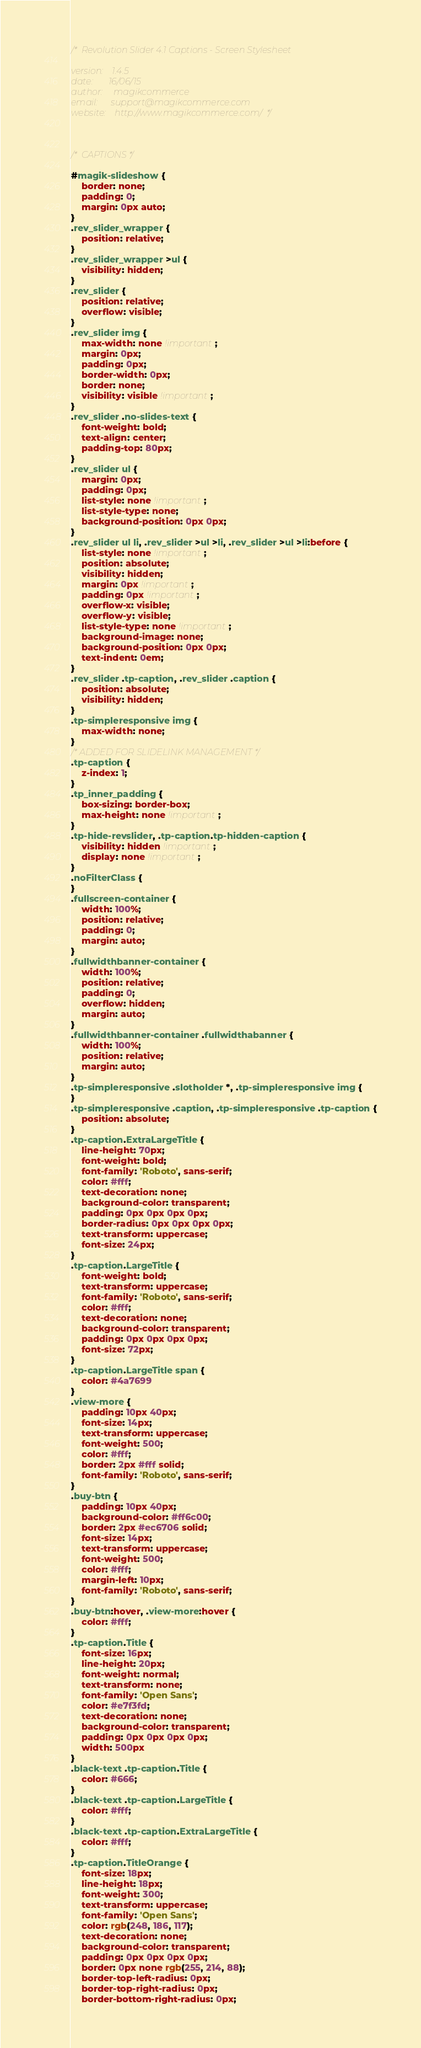Convert code to text. <code><loc_0><loc_0><loc_500><loc_500><_CSS_>/*	Revolution Slider 4.1 Captions - Screen Stylesheet

version:   	1.4.5
date:      	16/06/15
author:		magikcommerce
email:      support@magikcommerce.com
website:   	http://www.magikcommerce.com/  */



/*	CAPTIONS */

#magik-slideshow {
	border: none;
	padding: 0;
	margin: 0px auto;
}
.rev_slider_wrapper {
	position: relative;
}
.rev_slider_wrapper >ul {
	visibility: hidden;
}
.rev_slider {
	position: relative;
	overflow: visible;
}
.rev_slider img {
	max-width: none !important;
	margin: 0px;
	padding: 0px;
	border-width: 0px;
	border: none;
	visibility: visible !important;
}
.rev_slider .no-slides-text {
	font-weight: bold;
	text-align: center;
	padding-top: 80px;
}
.rev_slider ul {
	margin: 0px;
	padding: 0px;
	list-style: none !important;
	list-style-type: none;
	background-position: 0px 0px;
}
.rev_slider ul li, .rev_slider >ul >li, .rev_slider >ul >li:before {
	list-style: none !important;
	position: absolute;
	visibility: hidden;
	margin: 0px !important;
	padding: 0px !important;
	overflow-x: visible;
	overflow-y: visible;
	list-style-type: none !important;
	background-image: none;
	background-position: 0px 0px;
	text-indent: 0em;
}
.rev_slider .tp-caption, .rev_slider .caption {
	position: absolute;
	visibility: hidden;
}
.tp-simpleresponsive img {
	max-width: none;
}
/* ADDED FOR SLIDELINK MANAGEMENT */
.tp-caption {
	z-index: 1;
}
.tp_inner_padding {
	box-sizing: border-box;
	max-height: none !important;
}
.tp-hide-revslider, .tp-caption.tp-hidden-caption {
	visibility: hidden !important;
	display: none !important;
}
.noFilterClass {
}
.fullscreen-container {
	width: 100%;
	position: relative;
	padding: 0;
	margin: auto;
}
.fullwidthbanner-container {
	width: 100%;
	position: relative;
	padding: 0;
	overflow: hidden;
	margin: auto;
}
.fullwidthbanner-container .fullwidthabanner {
	width: 100%;
	position: relative;
	margin: auto;
}
.tp-simpleresponsive .slotholder *, .tp-simpleresponsive img {
}
.tp-simpleresponsive .caption, .tp-simpleresponsive .tp-caption {
	position: absolute;
}
.tp-caption.ExtraLargeTitle {
	line-height: 70px;
	font-weight: bold;
	font-family: 'Roboto', sans-serif;
	color: #fff;
	text-decoration: none;
	background-color: transparent;
	padding: 0px 0px 0px 0px;
	border-radius: 0px 0px 0px 0px;
	text-transform: uppercase;
	font-size: 24px;
}
.tp-caption.LargeTitle {
	font-weight: bold;
	text-transform: uppercase;
	font-family: 'Roboto', sans-serif;
	color: #fff;
	text-decoration: none;
	background-color: transparent;
	padding: 0px 0px 0px 0px;
	font-size: 72px;
}
.tp-caption.LargeTitle span {
	color: #4a7699
}
.view-more {
	padding: 10px 40px;
	font-size: 14px;
	text-transform: uppercase;
	font-weight: 500;
	color: #fff;
	border: 2px #fff solid;
	font-family: 'Roboto', sans-serif;
}
.buy-btn {
	padding: 10px 40px;
	background-color: #ff6c00;
	border: 2px #ec6706 solid;
	font-size: 14px;
	text-transform: uppercase;
	font-weight: 500;
	color: #fff;
	margin-left: 10px;
	font-family: 'Roboto', sans-serif;
}
.buy-btn:hover, .view-more:hover {
	color: #fff;
}
.tp-caption.Title {
	font-size: 16px;
	line-height: 20px;
	font-weight: normal;
	text-transform: none;
	font-family: 'Open Sans';
	color: #e7f3fd;
	text-decoration: none;
	background-color: transparent;
	padding: 0px 0px 0px 0px;
	width: 500px
}
.black-text .tp-caption.Title {
	color: #666;
}
.black-text .tp-caption.LargeTitle {
	color: #fff;
}
.black-text .tp-caption.ExtraLargeTitle {
	color: #fff;
}
.tp-caption.TitleOrange {
	font-size: 18px;
	line-height: 18px;
	font-weight: 300;
	text-transform: uppercase;
	font-family: 'Open Sans';
	color: rgb(248, 186, 117);
	text-decoration: none;
	background-color: transparent;
	padding: 0px 0px 0px 0px;
	border: 0px none rgb(255, 214, 88);
	border-top-left-radius: 0px;
	border-top-right-radius: 0px;
	border-bottom-right-radius: 0px;</code> 